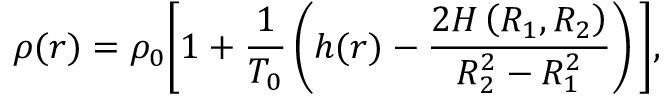Convert formula to latex. <formula><loc_0><loc_0><loc_500><loc_500>\rho ( r ) = \rho _ { 0 } \left [ 1 + \frac { 1 } { T _ { 0 } } \left ( h ( r ) - \frac { 2 H \left ( R _ { 1 } , R _ { 2 } \right ) } { R _ { 2 } ^ { 2 } - R _ { 1 } ^ { 2 } } \right ) \right ] ,</formula> 